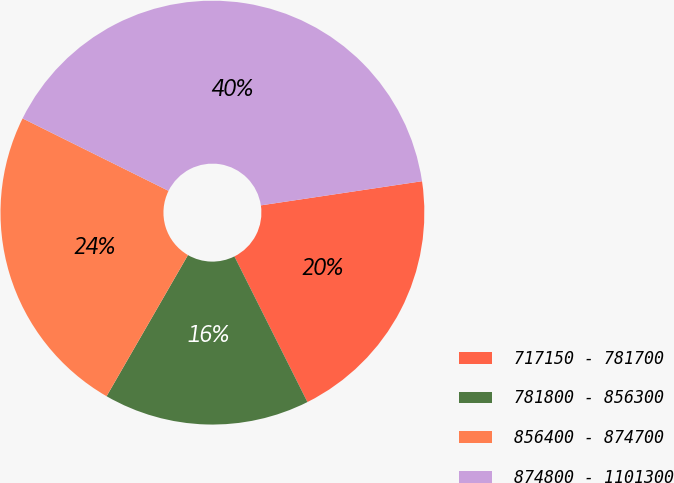Convert chart to OTSL. <chart><loc_0><loc_0><loc_500><loc_500><pie_chart><fcel>717150 - 781700<fcel>781800 - 856300<fcel>856400 - 874700<fcel>874800 - 1101300<nl><fcel>19.97%<fcel>15.72%<fcel>24.01%<fcel>40.3%<nl></chart> 